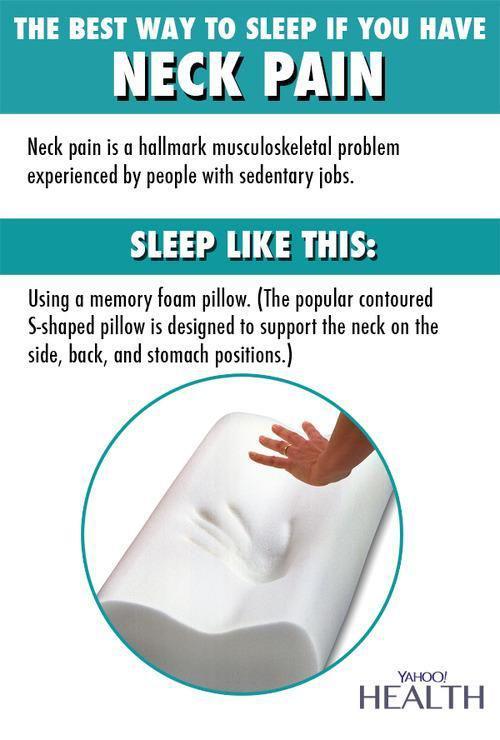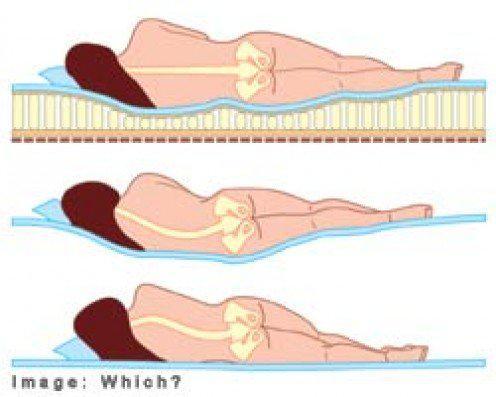The first image is the image on the left, the second image is the image on the right. For the images shown, is this caption "White pillows are arranged in front of an upholstered headboard in at least one image." true? Answer yes or no. No. 